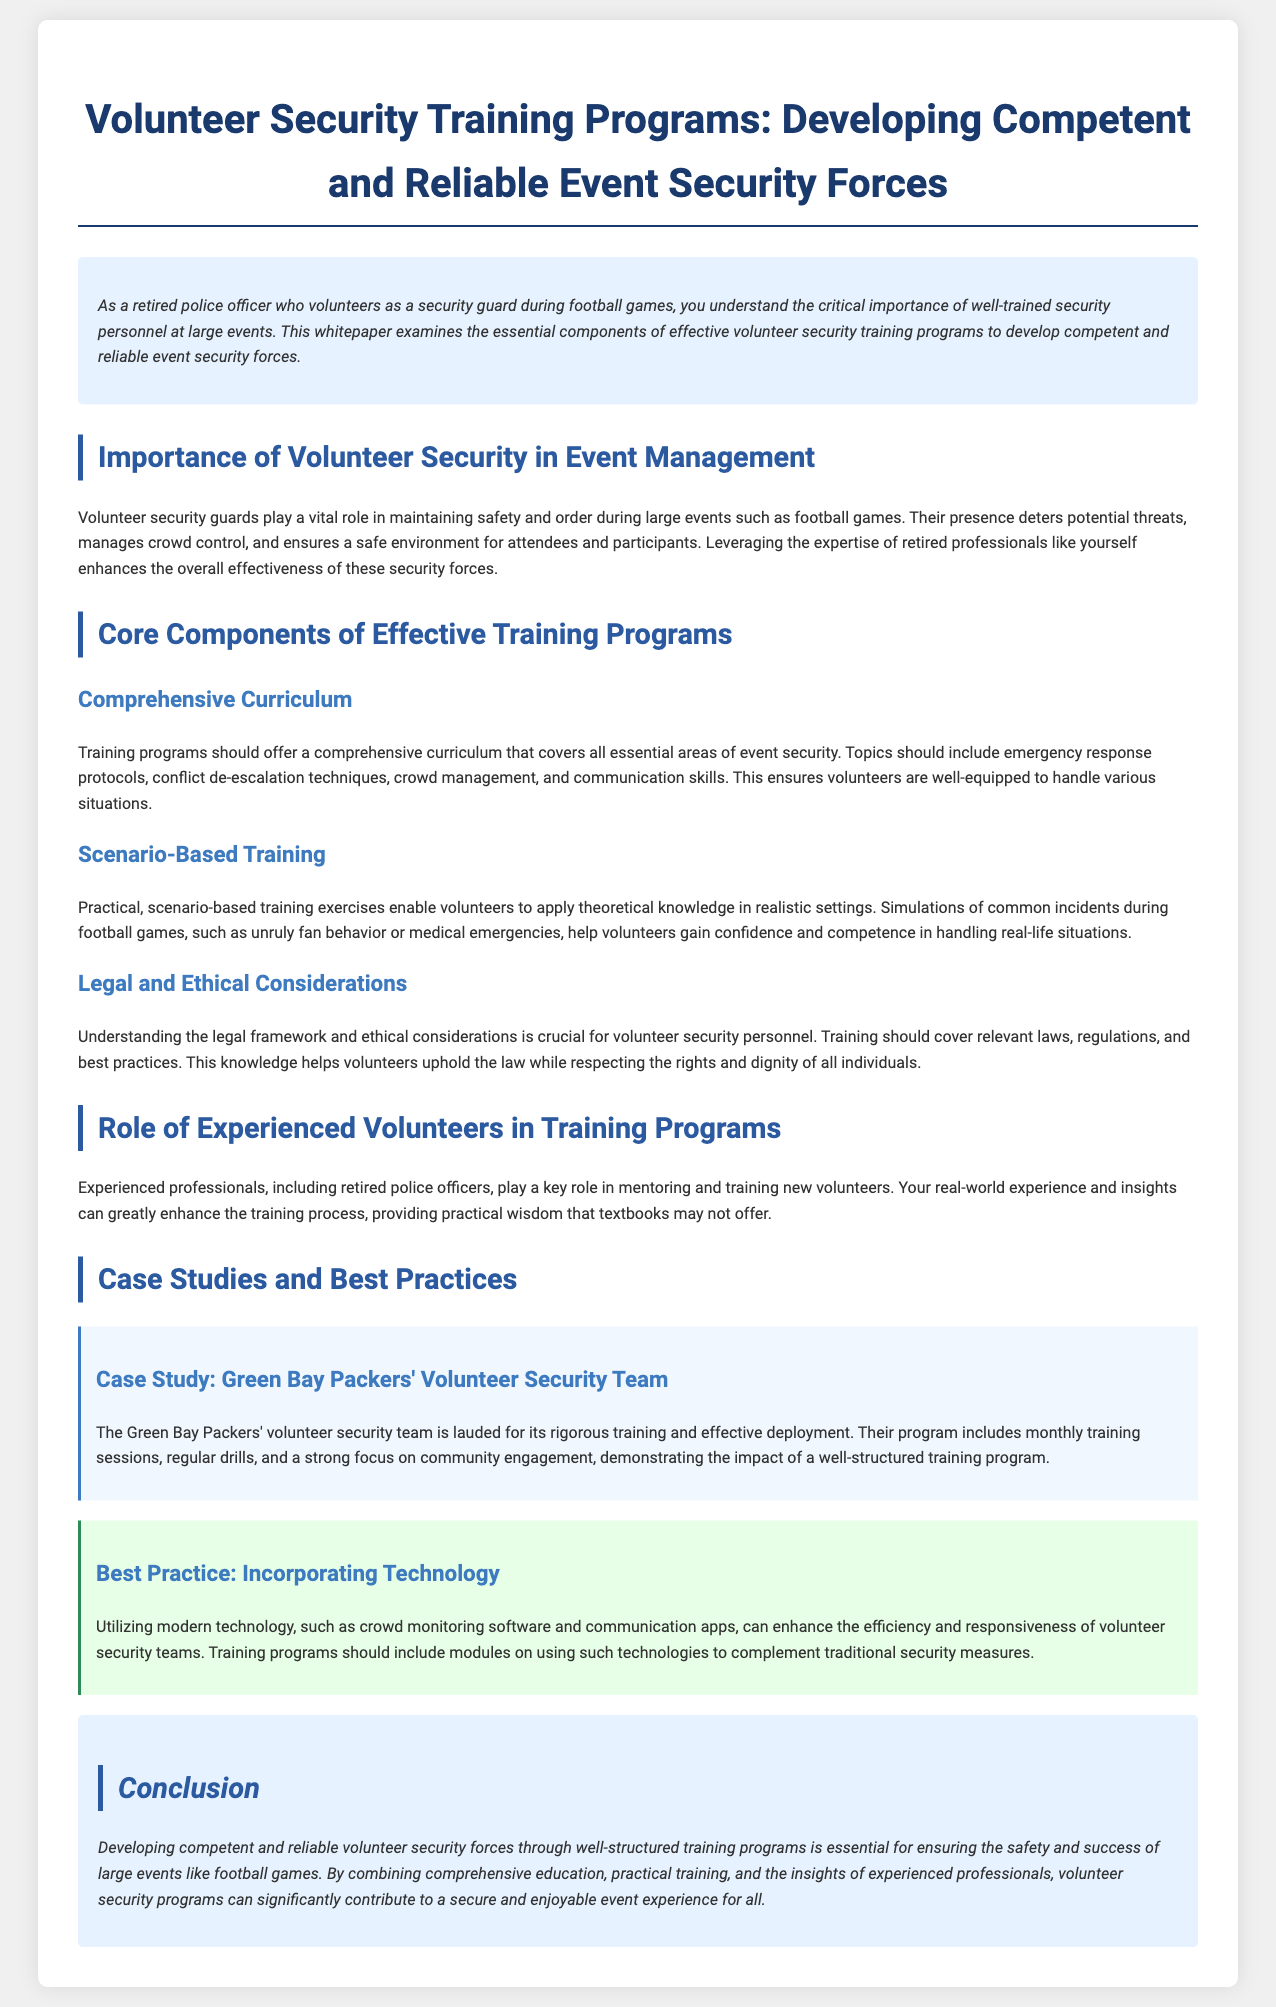What is the main focus of the whitepaper? The whitepaper focuses on developing competent and reliable event security forces through volunteer security training programs.
Answer: Developing competent and reliable event security forces What role do volunteer security guards play at events? Volunteer security guards maintain safety and order, manage crowd control, and ensure a safe environment for attendees.
Answer: Maintain safety and order What type of training includes simulations of common incidents? Scenario-based training includes simulations of common incidents that help volunteers gain confidence and competence.
Answer: Scenario-based training Who plays a key role in mentoring and training new volunteers? Experienced professionals, including retired police officers, play a key role in mentoring and training new volunteers.
Answer: Experienced professionals What notable aspect does the Green Bay Packers' volunteer security team emphasize? The Green Bay Packers' volunteer security team emphasizes rigorous training and community engagement in their program.
Answer: Rigorous training and community engagement Which best practice involves the use of modern technology? Incorporating technology, such as crowd monitoring software and communication apps, is a notable best practice in security training.
Answer: Incorporating technology What is the purpose of understanding legal and ethical considerations in training? Understanding legal and ethical considerations helps volunteers uphold the law while respecting rights and dignity.
Answer: Uphold the law while respecting rights What type of exercises do training programs provide to volunteers? Training programs provide practical, scenario-based exercises to apply theoretical knowledge.
Answer: Practical, scenario-based exercises 